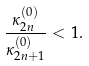Convert formula to latex. <formula><loc_0><loc_0><loc_500><loc_500>\frac { \kappa _ { 2 n } ^ { ( 0 ) } } { \kappa _ { 2 n + 1 } ^ { ( 0 ) } } < 1 .</formula> 